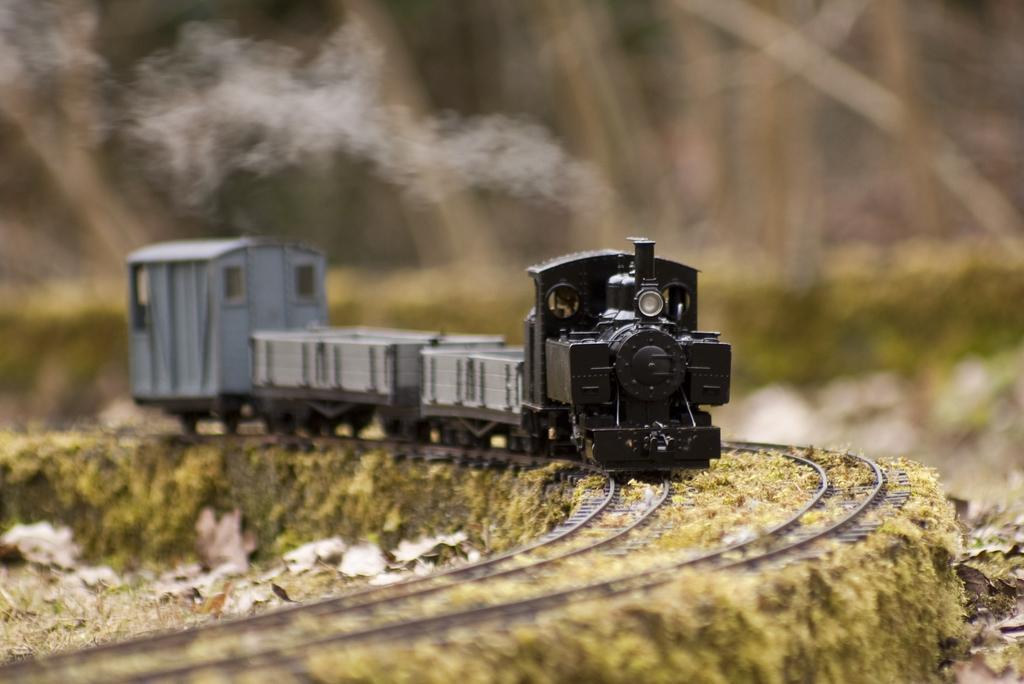How would you summarize this image in a sentence or two? In this image we can see a toy train on the track, there are dried leaves on the ground, there is a smoke, the background is blurry. 